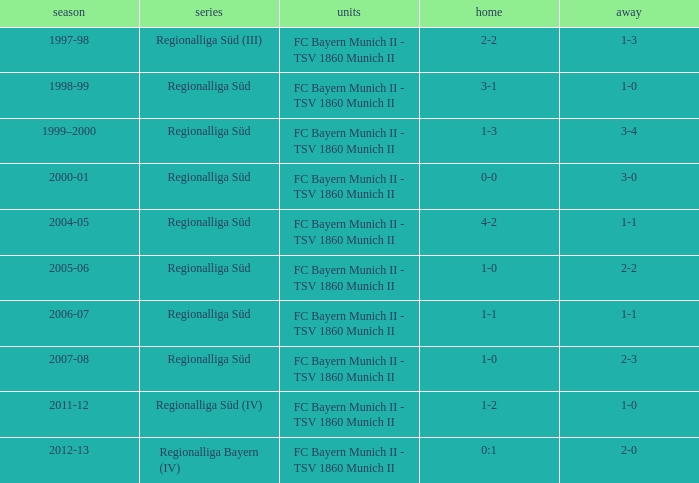What season has a regionalliga süd league, a 1-0 home, and an away of 2-3? 2007-08. 